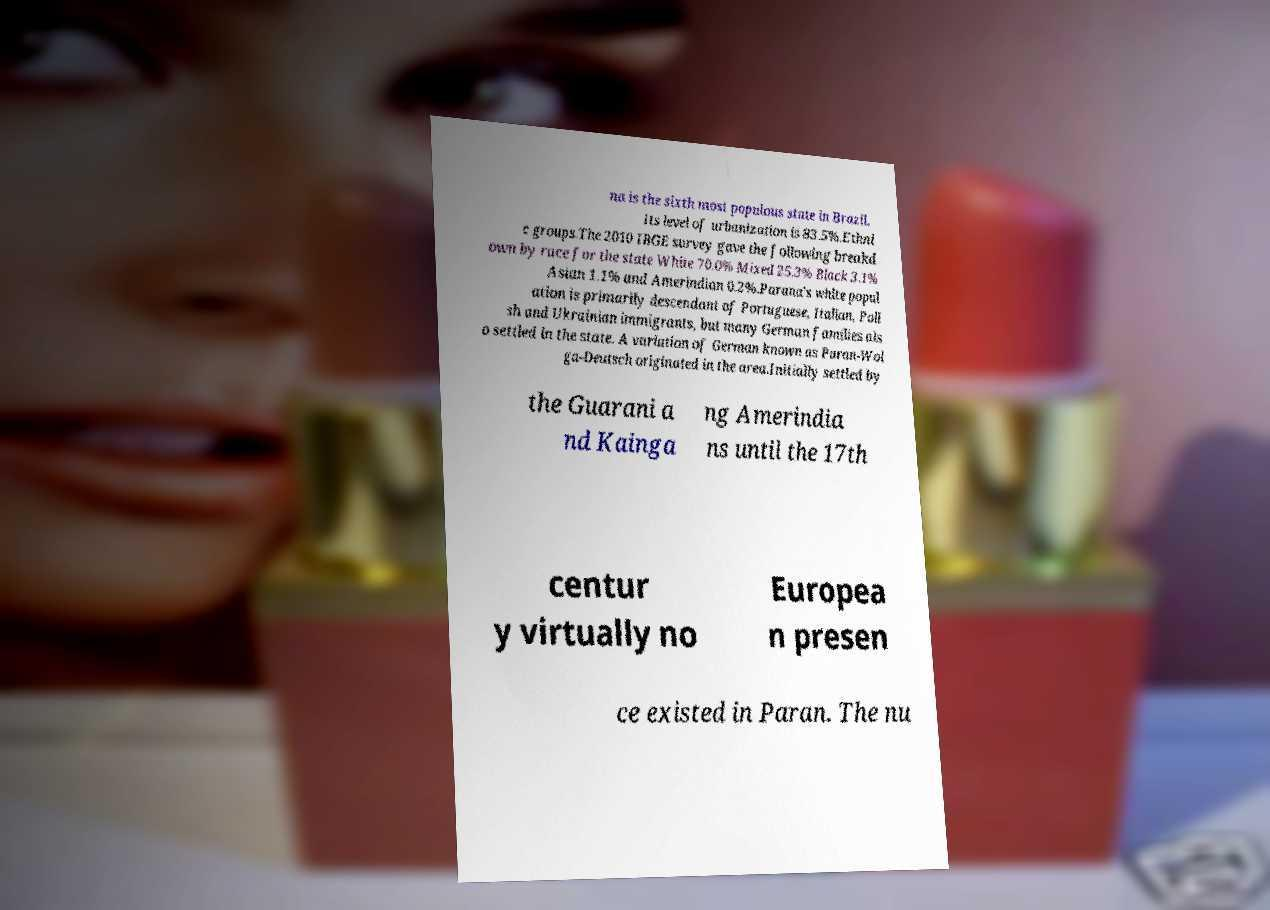Can you read and provide the text displayed in the image?This photo seems to have some interesting text. Can you extract and type it out for me? na is the sixth most populous state in Brazil. Its level of urbanization is 83.5%.Ethni c groups.The 2010 IBGE survey gave the following breakd own by race for the state White 70.0% Mixed 25.3% Black 3.1% Asian 1.1% and Amerindian 0.2%.Parana's white popul ation is primarily descendant of Portuguese, Italian, Poli sh and Ukrainian immigrants, but many German families als o settled in the state. A variation of German known as Paran-Wol ga-Deutsch originated in the area.Initially settled by the Guarani a nd Kainga ng Amerindia ns until the 17th centur y virtually no Europea n presen ce existed in Paran. The nu 